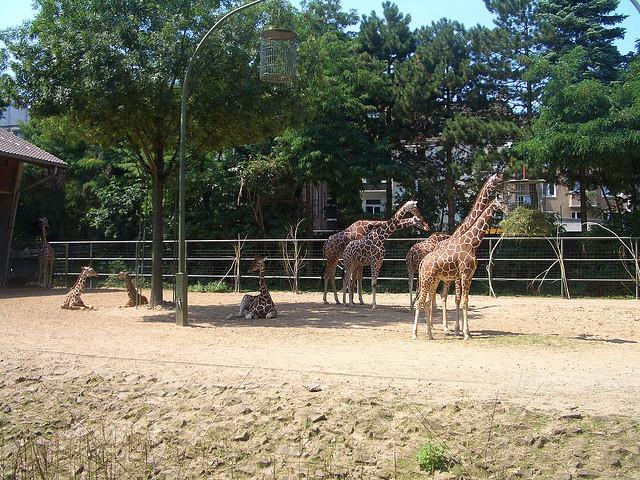What is the giraffe in the middle resting in?

Choices:
A) hay
B) grass
C) shade
D) bath shade 